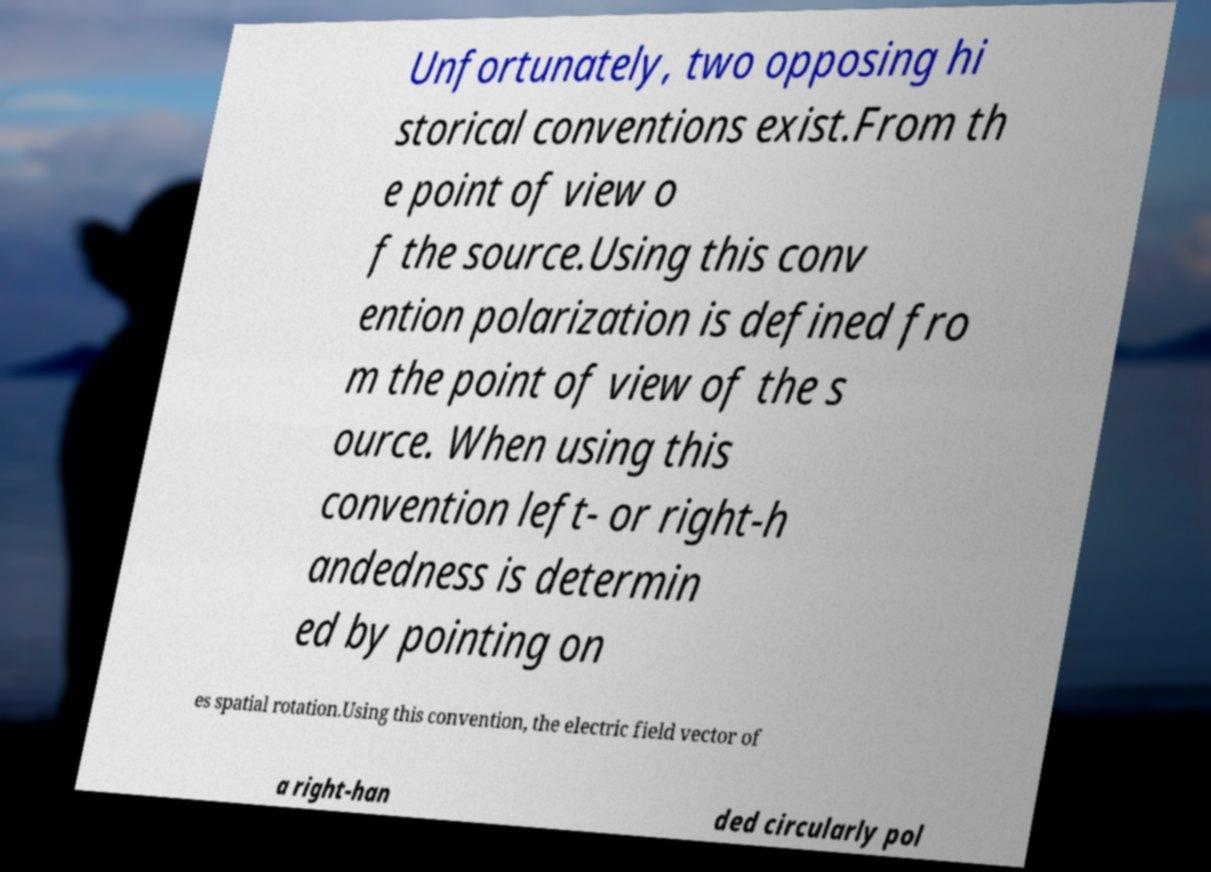Please read and relay the text visible in this image. What does it say? Unfortunately, two opposing hi storical conventions exist.From th e point of view o f the source.Using this conv ention polarization is defined fro m the point of view of the s ource. When using this convention left- or right-h andedness is determin ed by pointing on es spatial rotation.Using this convention, the electric field vector of a right-han ded circularly pol 